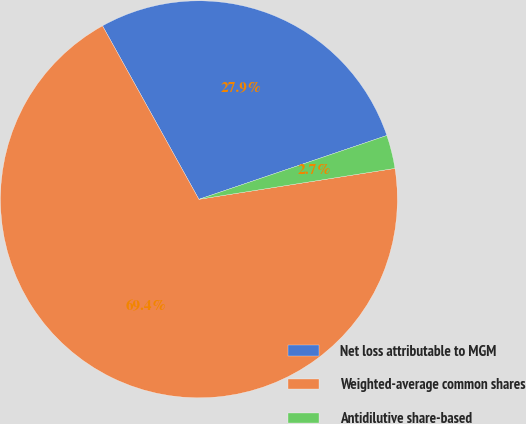Convert chart. <chart><loc_0><loc_0><loc_500><loc_500><pie_chart><fcel>Net loss attributable to MGM<fcel>Weighted-average common shares<fcel>Antidilutive share-based<nl><fcel>27.86%<fcel>69.41%<fcel>2.72%<nl></chart> 